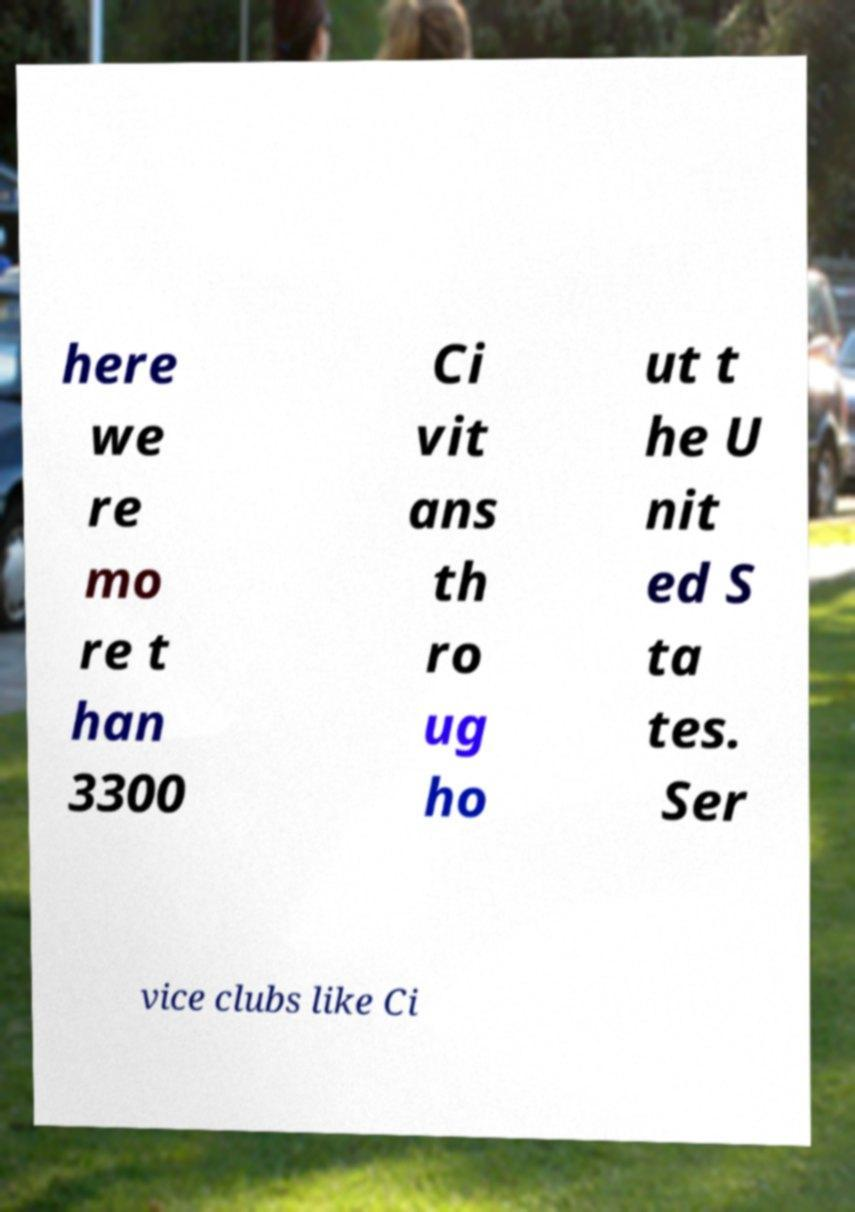Could you assist in decoding the text presented in this image and type it out clearly? here we re mo re t han 3300 Ci vit ans th ro ug ho ut t he U nit ed S ta tes. Ser vice clubs like Ci 